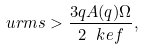Convert formula to latex. <formula><loc_0><loc_0><loc_500><loc_500>\ u r m s > \frac { 3 q A ( q ) \Omega } { 2 \ k e f } ,</formula> 